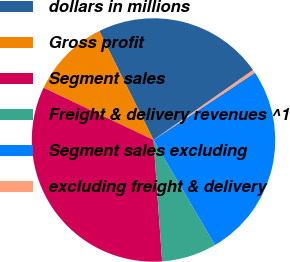Convert chart. <chart><loc_0><loc_0><loc_500><loc_500><pie_chart><fcel>dollars in millions<fcel>Gross profit<fcel>Segment sales<fcel>Freight & delivery revenues ^1<fcel>Segment sales excluding<fcel>excluding freight & delivery<nl><fcel>22.6%<fcel>10.59%<fcel>33.2%<fcel>7.31%<fcel>25.89%<fcel>0.42%<nl></chart> 